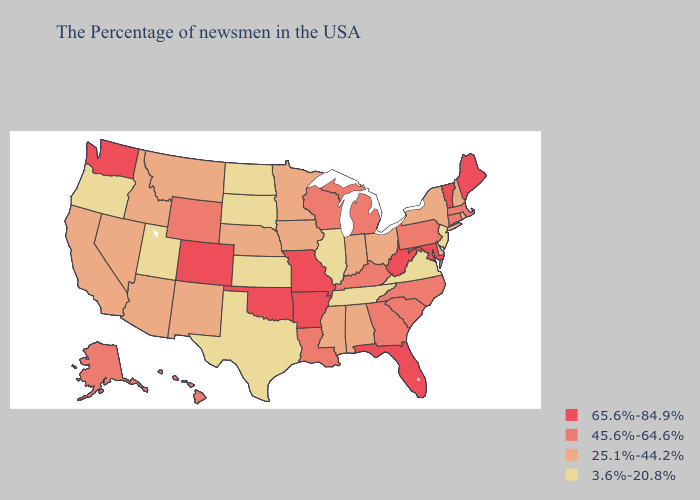Does Kansas have the same value as Minnesota?
Be succinct. No. Does Pennsylvania have the lowest value in the Northeast?
Concise answer only. No. Name the states that have a value in the range 25.1%-44.2%?
Short answer required. Rhode Island, New Hampshire, New York, Delaware, Ohio, Indiana, Alabama, Mississippi, Minnesota, Iowa, Nebraska, New Mexico, Montana, Arizona, Idaho, Nevada, California. Name the states that have a value in the range 25.1%-44.2%?
Be succinct. Rhode Island, New Hampshire, New York, Delaware, Ohio, Indiana, Alabama, Mississippi, Minnesota, Iowa, Nebraska, New Mexico, Montana, Arizona, Idaho, Nevada, California. Does the map have missing data?
Keep it brief. No. What is the value of Indiana?
Write a very short answer. 25.1%-44.2%. What is the value of New Hampshire?
Concise answer only. 25.1%-44.2%. Which states hav the highest value in the MidWest?
Quick response, please. Missouri. Name the states that have a value in the range 45.6%-64.6%?
Quick response, please. Massachusetts, Connecticut, Pennsylvania, North Carolina, South Carolina, Georgia, Michigan, Kentucky, Wisconsin, Louisiana, Wyoming, Alaska, Hawaii. Name the states that have a value in the range 65.6%-84.9%?
Short answer required. Maine, Vermont, Maryland, West Virginia, Florida, Missouri, Arkansas, Oklahoma, Colorado, Washington. Name the states that have a value in the range 65.6%-84.9%?
Be succinct. Maine, Vermont, Maryland, West Virginia, Florida, Missouri, Arkansas, Oklahoma, Colorado, Washington. Does Connecticut have the lowest value in the Northeast?
Keep it brief. No. Name the states that have a value in the range 3.6%-20.8%?
Write a very short answer. New Jersey, Virginia, Tennessee, Illinois, Kansas, Texas, South Dakota, North Dakota, Utah, Oregon. What is the highest value in the South ?
Short answer required. 65.6%-84.9%. Name the states that have a value in the range 25.1%-44.2%?
Be succinct. Rhode Island, New Hampshire, New York, Delaware, Ohio, Indiana, Alabama, Mississippi, Minnesota, Iowa, Nebraska, New Mexico, Montana, Arizona, Idaho, Nevada, California. 